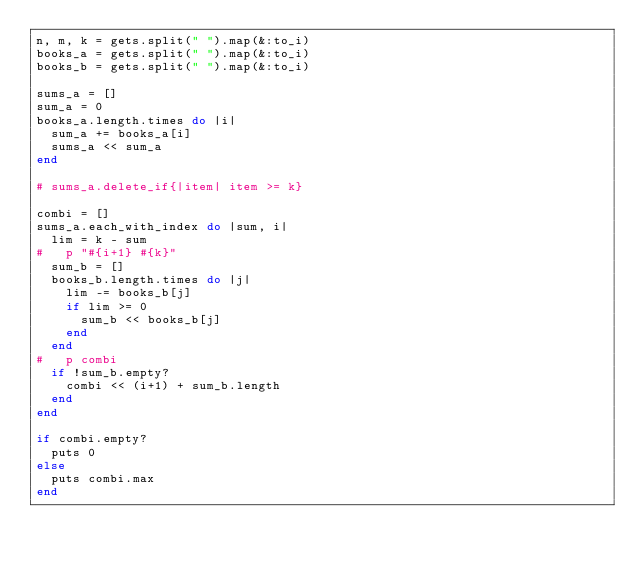Convert code to text. <code><loc_0><loc_0><loc_500><loc_500><_Ruby_>n, m, k = gets.split(" ").map(&:to_i)
books_a = gets.split(" ").map(&:to_i)
books_b = gets.split(" ").map(&:to_i)

sums_a = []
sum_a = 0
books_a.length.times do |i|
  sum_a += books_a[i]
  sums_a << sum_a
end

# sums_a.delete_if{|item| item >= k}

combi = []
sums_a.each_with_index do |sum, i|
  lim = k - sum
#   p "#{i+1} #{k}"
  sum_b = []
  books_b.length.times do |j|
    lim -= books_b[j]
    if lim >= 0
      sum_b << books_b[j]
    end
  end
#   p combi
  if !sum_b.empty?
    combi << (i+1) + sum_b.length
  end
end

if combi.empty?
  puts 0
else
  puts combi.max
end</code> 